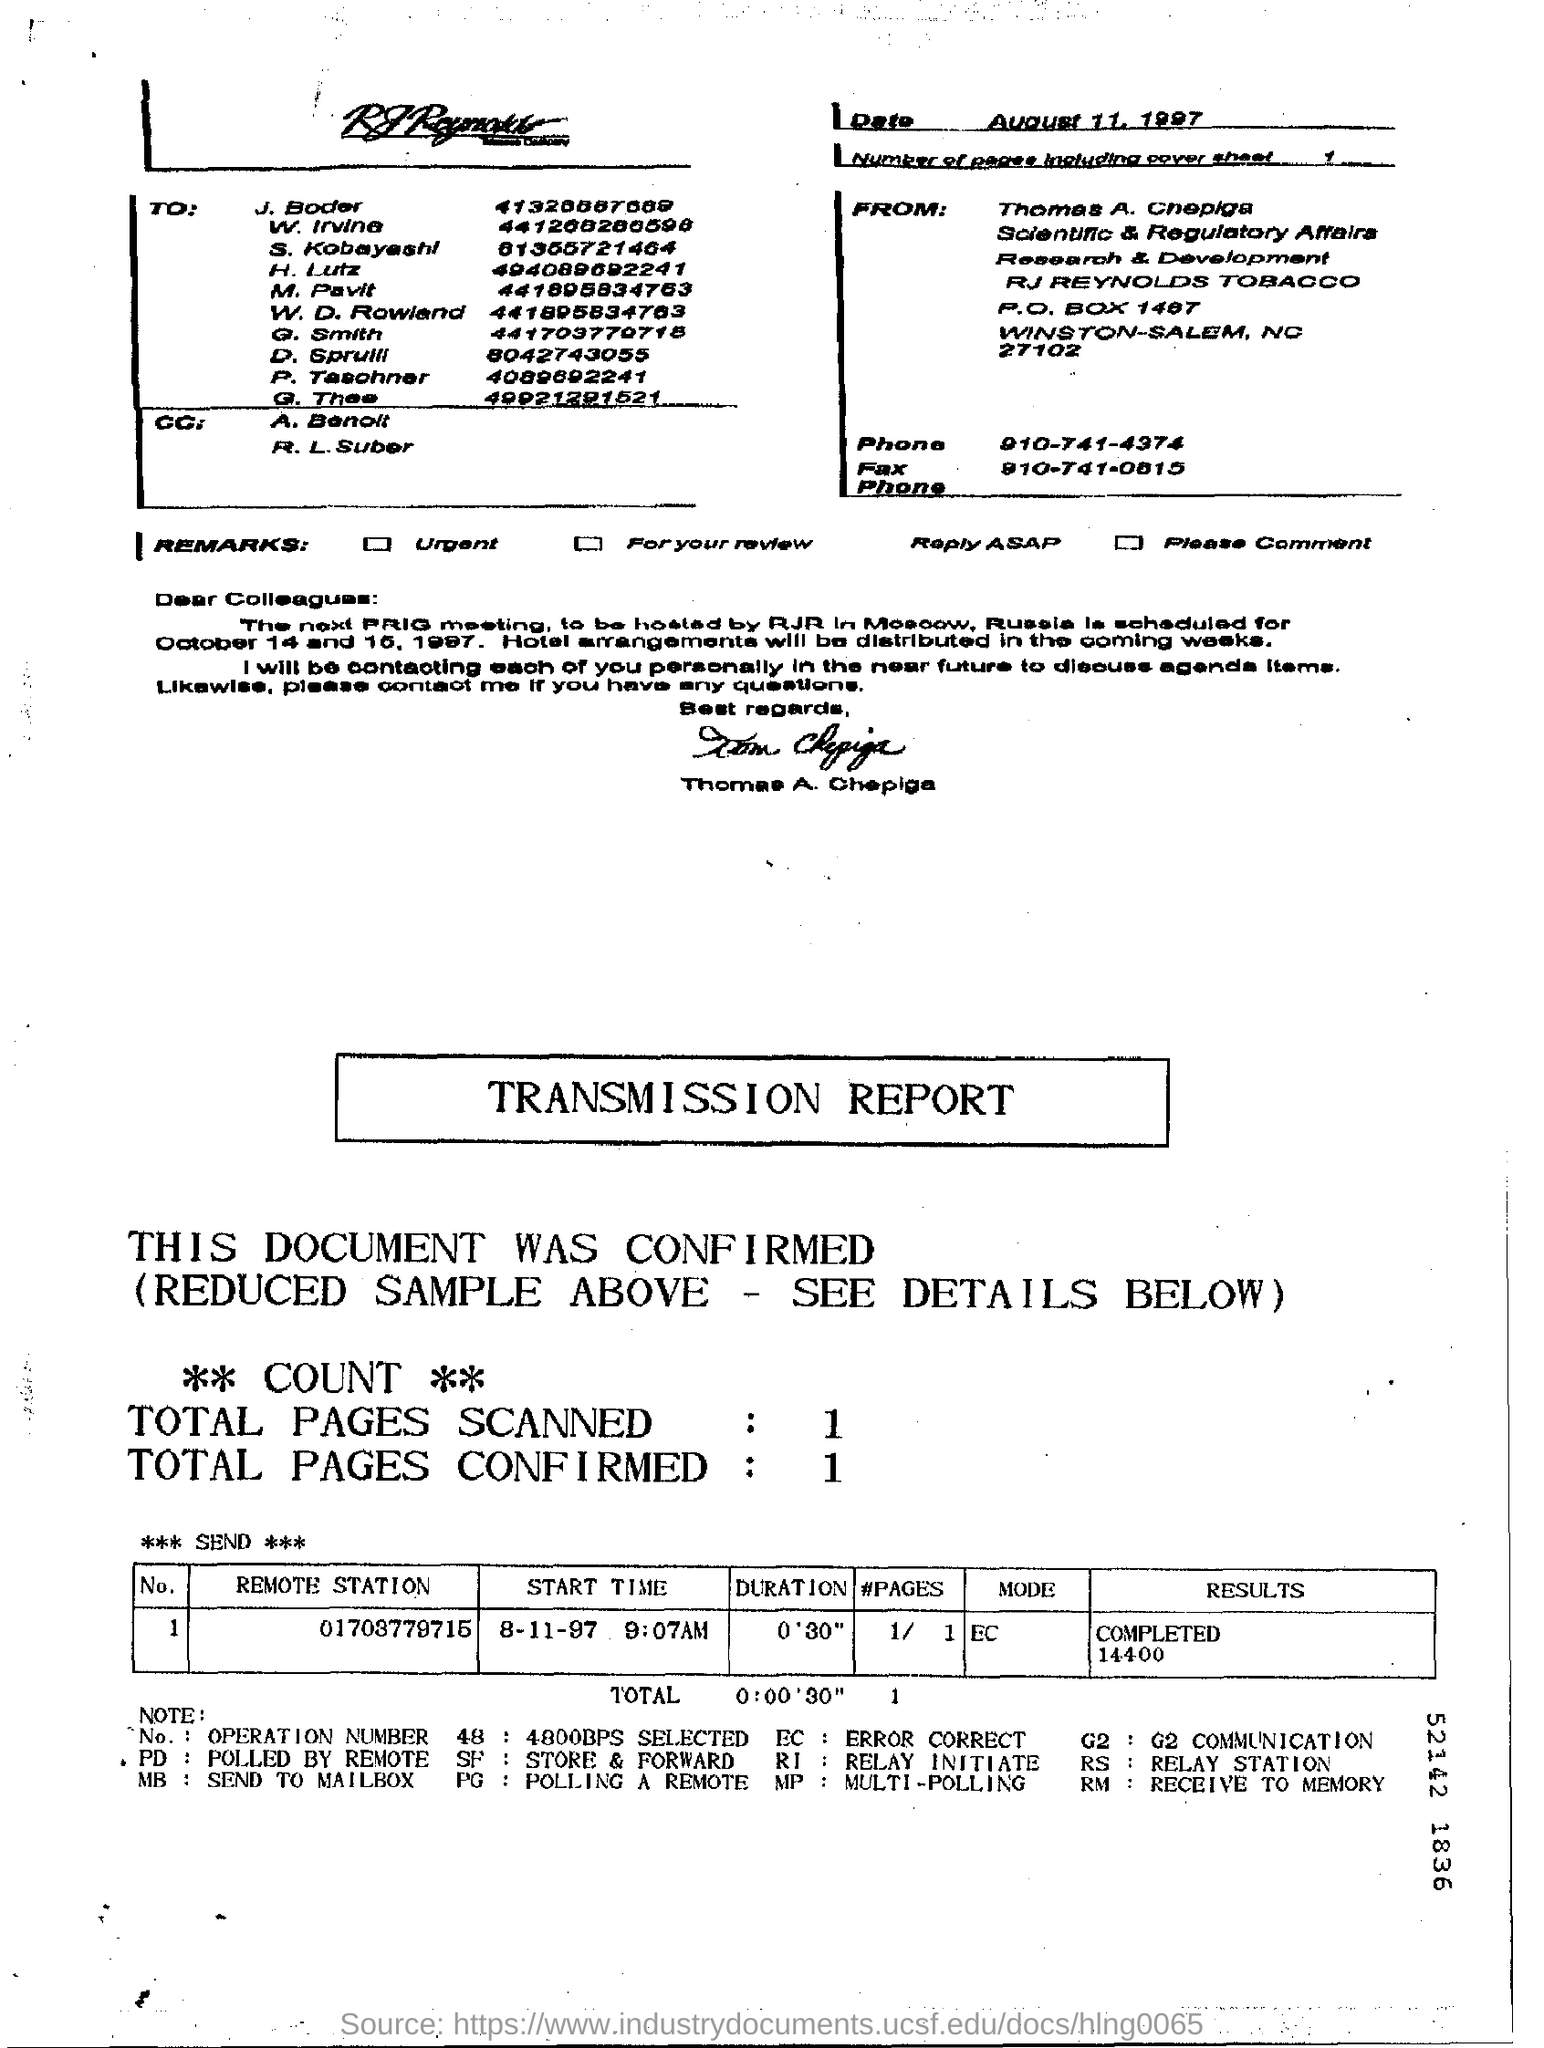What is the date on the Fax?
Offer a terse response. August 11, 1997. What is the "Start Time" for "Remote Station" "01703779715"?
Your response must be concise. 8-11-97 9:07AM. What is the "MODE" for "Remote Station" "01703779715"?
Ensure brevity in your answer.  EC. What is the "RESULTS" for "Remote Station" "01703779715"?
Provide a succinct answer. 14400. What are the Total Pages Scanned?
Give a very brief answer. 1. What are the Total Pages Confirmed?
Your answer should be compact. 1. 